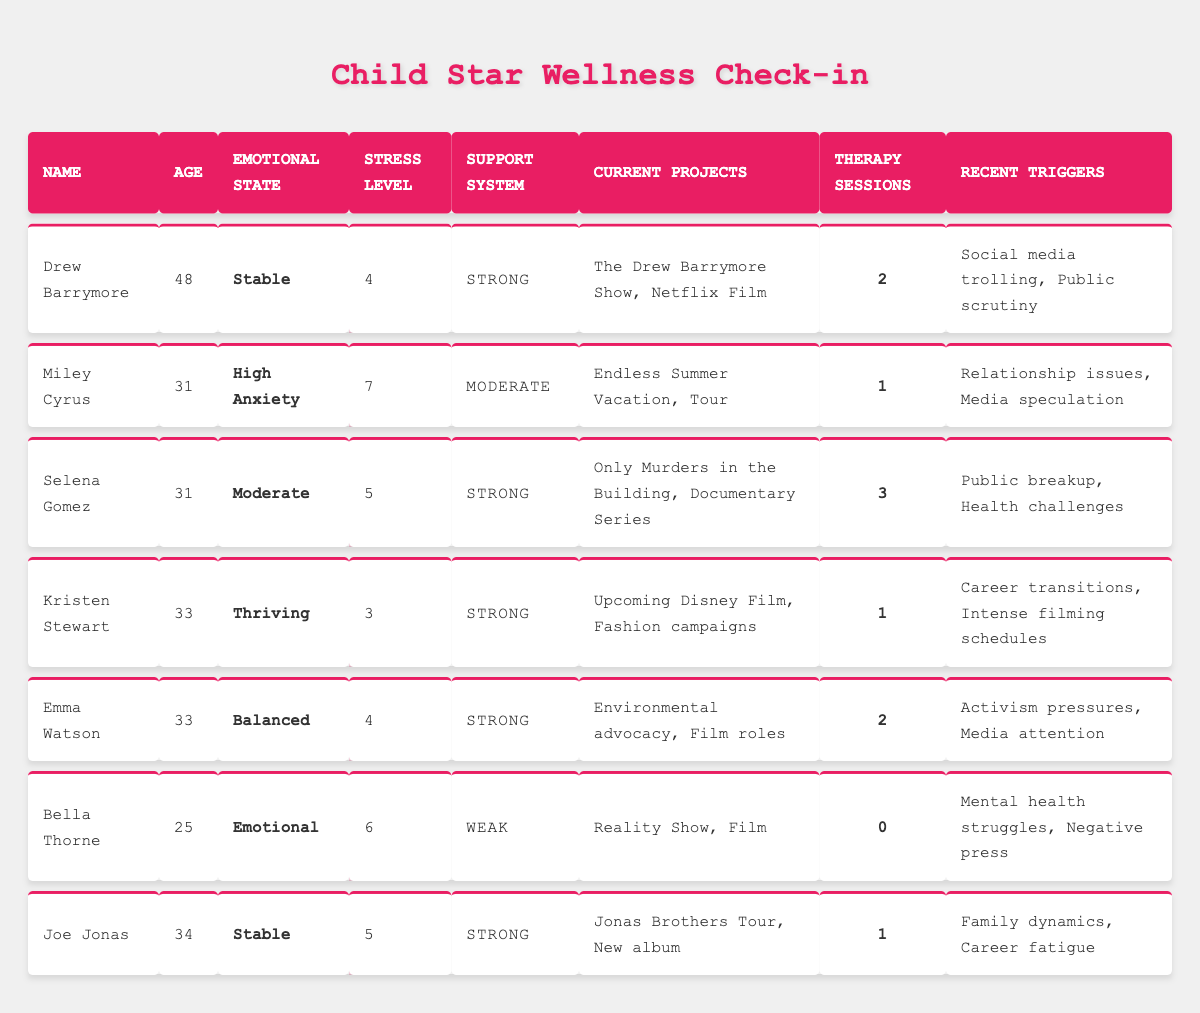What is the emotional state of Miley Cyrus? From the table, we can see that Miley Cyrus has an emotional state listed as "High Anxiety."
Answer: High Anxiety How many therapy sessions has Selena Gomez attended? The table indicates that Selena Gomez has attended 3 therapy sessions.
Answer: 3 Which child star has the lowest stress level? By comparing the stress levels in the table, Kristen Stewart has the lowest stress level of 3.
Answer: 3 Who has a weak support system? According to the table, Bella Thorne has a weak support system.
Answer: Bella Thorne What are the recent triggers for Drew Barrymore? The table lists Drew Barrymore's recent triggers as "Social media trolling" and "Public scrutiny."
Answer: Social media trolling, Public scrutiny What is the average stress level of the child stars listed? To find the average stress level, we add all the stress levels: 4 + 7 + 5 + 3 + 4 + 6 + 5 = 34. There are 7 child stars, so the average is 34/7 = 4.86.
Answer: 4.86 Which child star has the most therapy sessions? Comparing the therapy sessions from the table, Selena Gomez has the highest number with 3 sessions.
Answer: Selena Gomez Is Bella Thorne thriving emotionally? No, the table indicates Bella Thorne is emotionally in a state described as "Emotional," which suggests she is not thriving.
Answer: No What emotional state does Joe Jonas have? From the table, Joe Jonas has an emotional state labeled as "Stable."
Answer: Stable Which of the child stars has a strong support system and low stress? Kristen Stewart and Selena Gomez both have strong support systems, but Kristen Stewart has the lower stress level of 3.
Answer: Kristen Stewart 